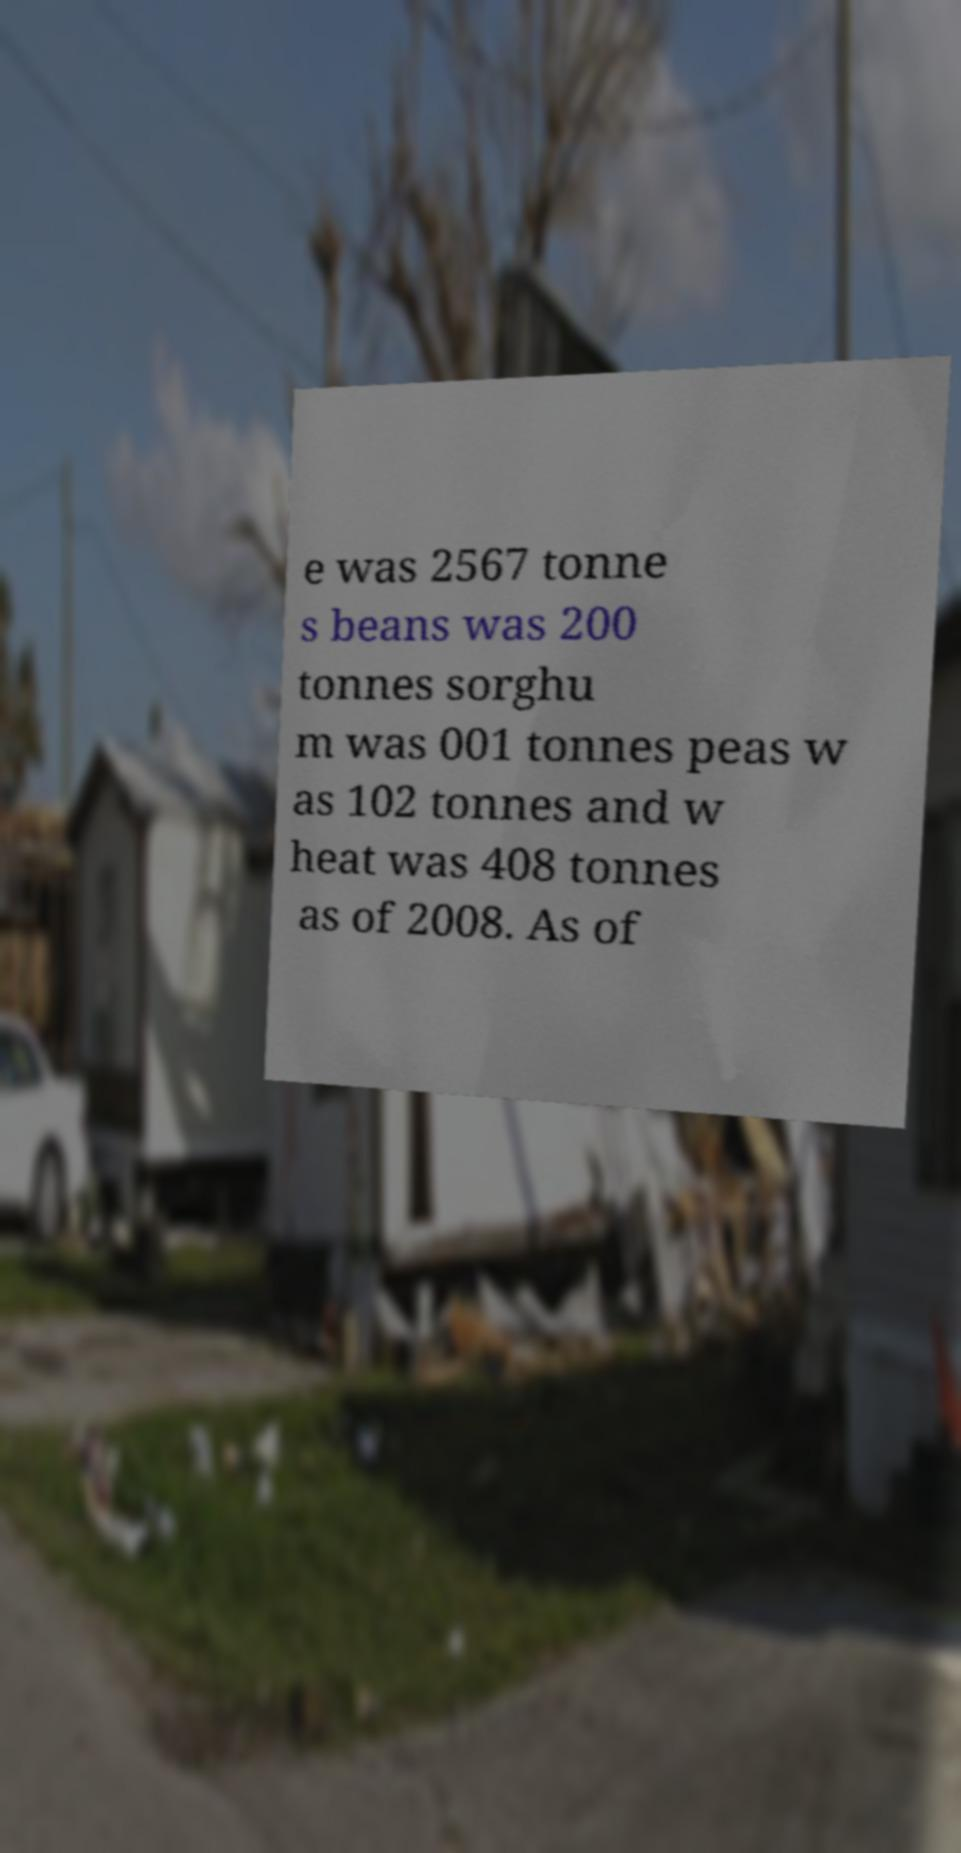Can you read and provide the text displayed in the image?This photo seems to have some interesting text. Can you extract and type it out for me? e was 2567 tonne s beans was 200 tonnes sorghu m was 001 tonnes peas w as 102 tonnes and w heat was 408 tonnes as of 2008. As of 